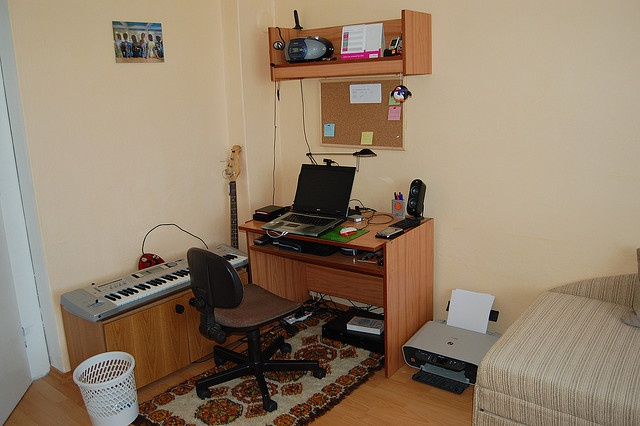Describe the objects in this image and their specific colors. I can see couch in gray and darkgray tones, chair in gray, black, and maroon tones, laptop in gray, black, and tan tones, book in gray, black, and darkgray tones, and remote in black, maroon, and gray tones in this image. 